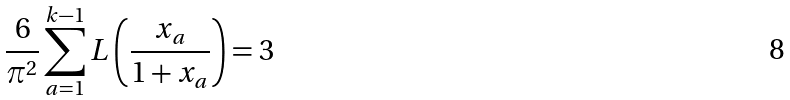<formula> <loc_0><loc_0><loc_500><loc_500>\frac { 6 } { \pi ^ { 2 } } \sum _ { a = 1 } ^ { k - 1 } L \left ( \frac { x _ { a } } { 1 + x _ { a } } \right ) = 3 \,</formula> 